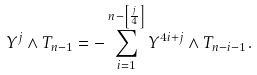Convert formula to latex. <formula><loc_0><loc_0><loc_500><loc_500>Y ^ { j } \wedge T _ { n - 1 } = - \sum _ { i = 1 } ^ { n - \left [ \frac { j } { 4 } \right ] } Y ^ { 4 i + j } \wedge T _ { n - i - 1 } .</formula> 